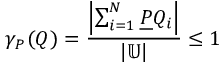Convert formula to latex. <formula><loc_0><loc_0><loc_500><loc_500>\gamma _ { P } ( Q ) = { \frac { \left | \sum _ { i = 1 } ^ { N } { \underline { P } } Q _ { i } \right | } { \left | \mathbb { U } \right | } } \leq 1</formula> 